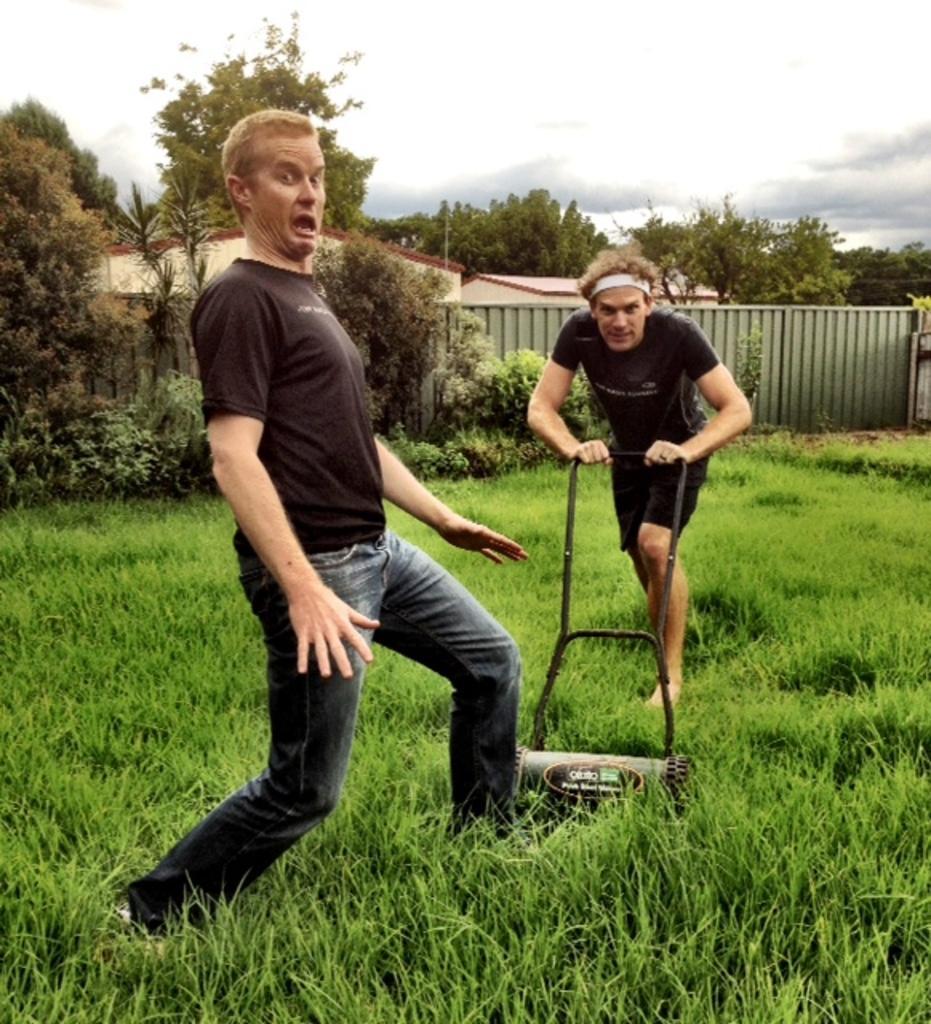Could you give a brief overview of what you see in this image? On the left side, there is a person in a black color shirt on the grass on the ground. On the right side, there is another person in a black color dress, holding the handles of the machine, which is on the grass. In the background, there is a wall, there are trees, buildings, plants and there are clouds in the sky. 